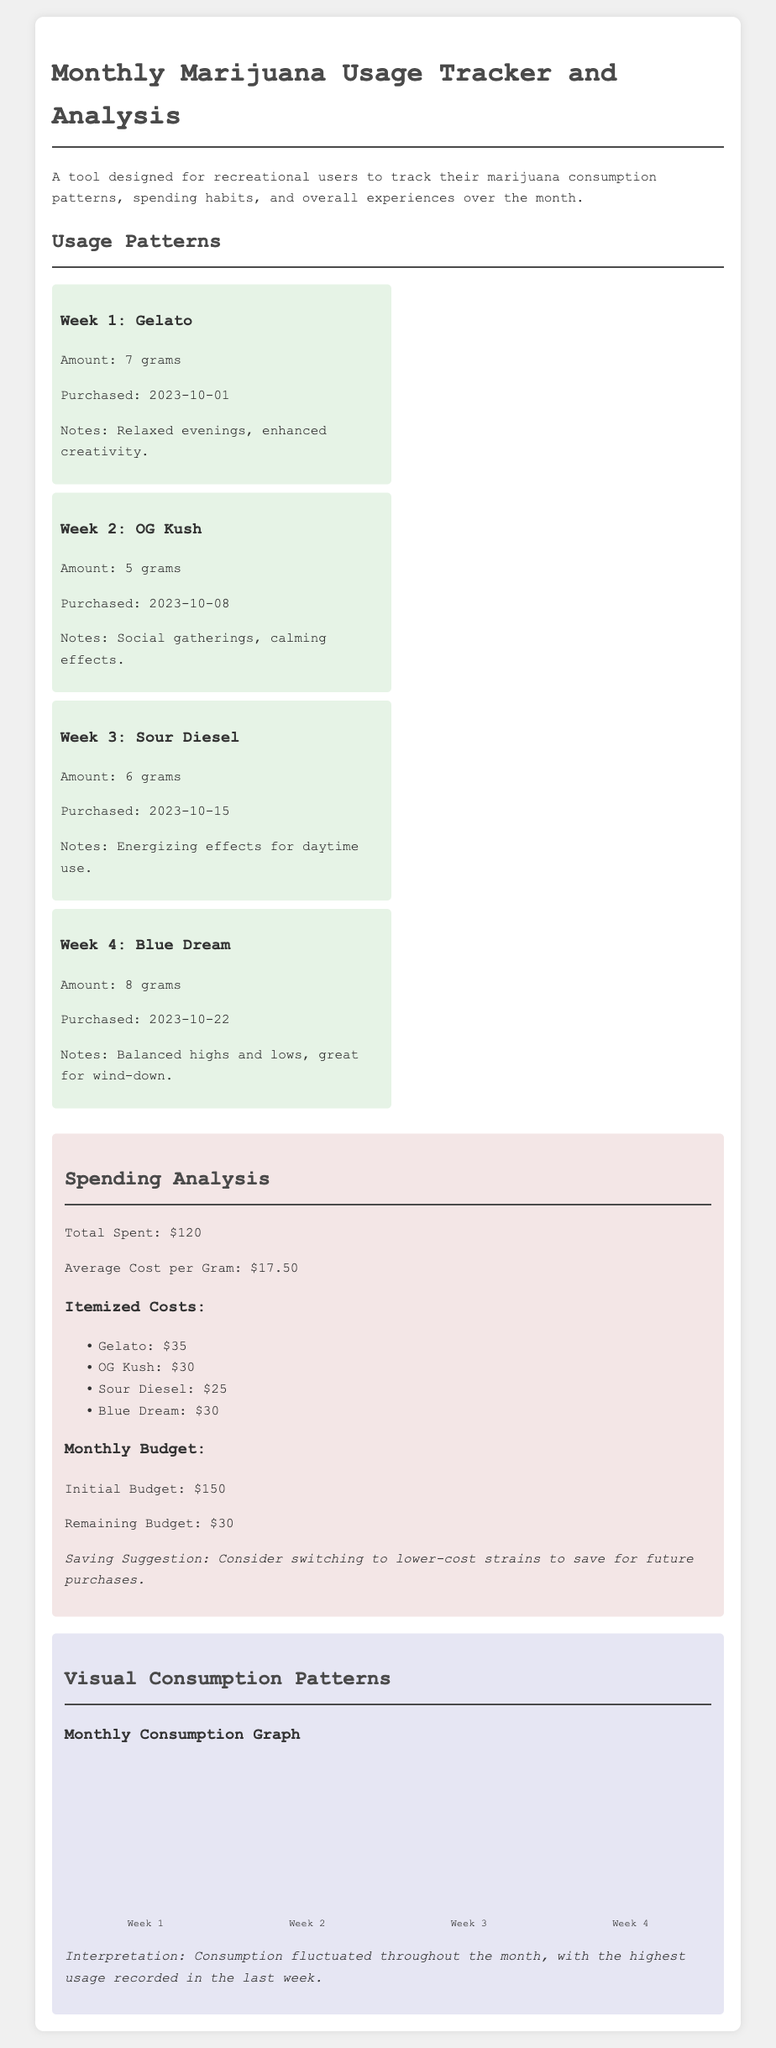What was the total amount of marijuana used in Week 1? The total amount used in Week 1 is stated as 7 grams.
Answer: 7 grams What strain was purchased in Week 3? The strain purchased in Week 3 is mentioned as Sour Diesel.
Answer: Sour Diesel What is the average cost per gram of marijuana? The average cost per gram is provided as $17.50.
Answer: $17.50 How much was spent on Blue Dream? The cost for Blue Dream is itemized as $30.
Answer: $30 Which week showed the highest marijuana usage? The week with the highest usage can be found by comparing consumption levels, with Week 4 having 80%.
Answer: Week 4 What is the remaining budget after expenditures? The remaining budget is provided as $30 after the initial budget and total spent are taken into account.
Answer: $30 How many grams were purchased in Week 2? Week 2 shows an amount of 5 grams purchased.
Answer: 5 grams What is one saving suggestion mentioned in the spending analysis? The document suggests considering switching to lower-cost strains to save money.
Answer: Lower-cost strains What was the total amount spent for all strains? The total amount spent is summed as $120 across all purchases.
Answer: $120 